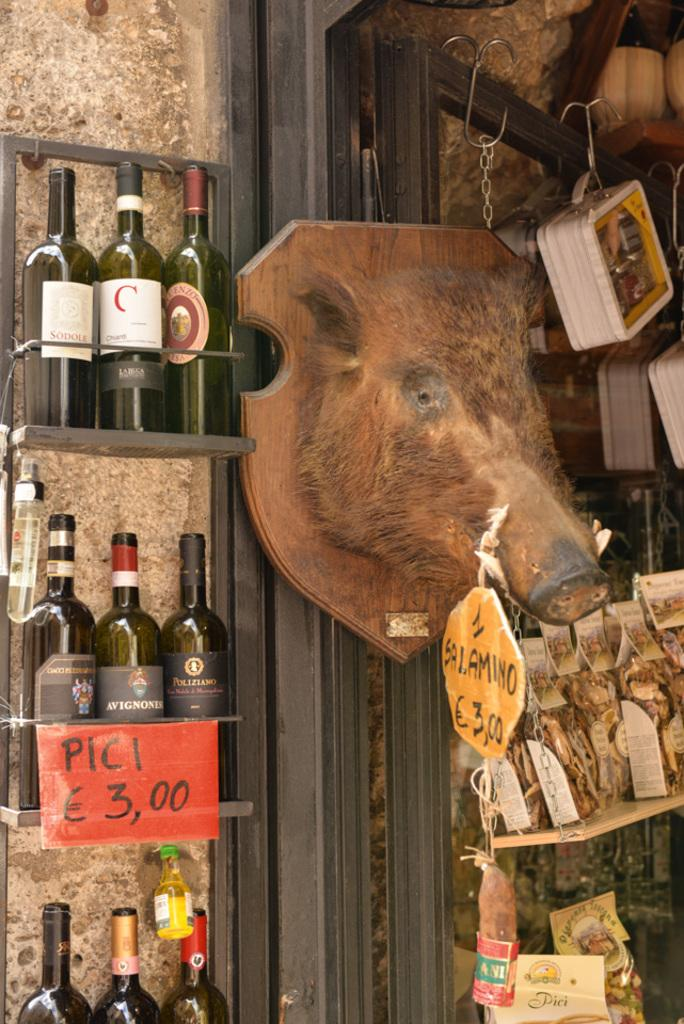What type of items can be seen in the image? There are beverage bottles in the image. Where are the bottles located? The bottles are arranged in cupboards. What information is available about the items in the image? Price tags are present in the image. What type of decor can be seen in the image? There is decor visible in the image. How are the serving trays arranged in the image? Serving trays are hanged on hooks in the image. How many snakes are slithering on the floor in the image? There are no snakes present in the image. What class of items are the beverage bottles categorized as in the image? The image does not provide information about the class of items the beverage bottles belong to. 